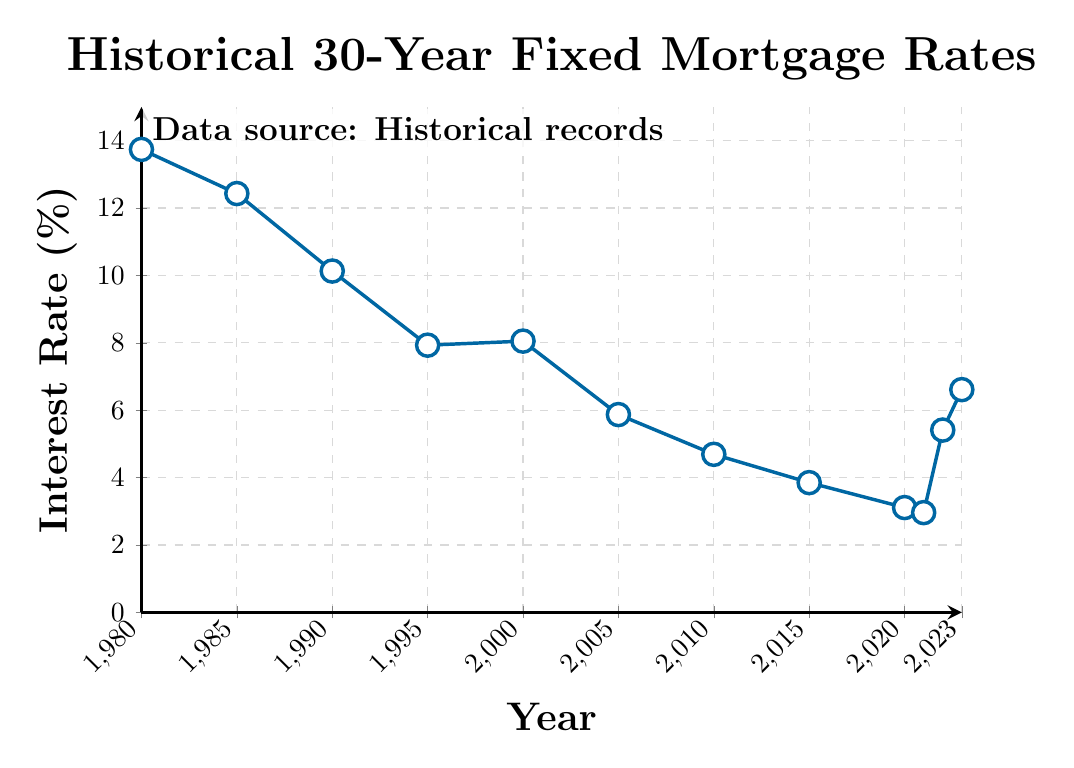What's the lowest interest rate depicted in the chart? Find the lowest point on the line representing interest rates throughout the years. The interest rate in 2021 is 2.96%, which is the lowest point on the chart.
Answer: 2.96% How does the interest rate in 2005 compare to that in 2020? Look at the interest rates for the years 2005 and 2020 and compare them. In 2005, the interest rate was 5.87%. In 2020, it was 3.11%.
Answer: The interest rate in 2005 was higher than in 2020 What is the difference in interest rates between 1980 and 2023? Subtract the interest rate in 2023 from the interest rate in 1980. The rate in 1980 was 13.74%, and in 2023 it was 6.61%. So, 13.74% - 6.61% = 7.13%.
Answer: 7.13% During which decade did the interest rate experience the most significant drop? Check the interest rate values at the start and end of each decade and find the decade with the largest decrease. The most significant drop occurred between 1980 (13.74%) and 1990 (10.13%) which is a decrease of 3.61%.
Answer: 1980s What is the average interest rate from 2010 to 2023? Sum the interest rates for the years 2010, 2015, 2020, 2021, 2022, and 2023 and then divide by the number of years. (4.69 + 3.85 + 3.11 + 2.96 + 5.41 + 6.61) / 6 = 26.63 / 6 ≈ 4.44%
Answer: 4.44% Which year had a higher interest rate: 1990 or 2000? Compare the interest rates for 1990 and 2000. In 1990, the rate was 10.13%, and in 2000, it was 8.05%.
Answer: 1990 In which year did the interest rate first drop below 5%? Check the trend of the line and identify the year where the rate first falls below 5%. The rate drops below 5% for the first time in 2010, where it was 4.69%.
Answer: 2010 How did the interest rate change from 1985 to 1995? Look at the interest rates for 1985 and 1995 and find the change by subtracting the latter from the former. The rate in 1985 was 12.43%, and in 1995 it was 7.93%, so the change is 12.43% - 7.93% = 4.50%.
Answer: The interest rate decreased by 4.50% 